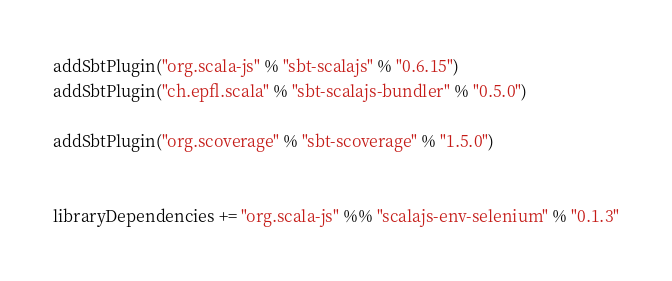Convert code to text. <code><loc_0><loc_0><loc_500><loc_500><_Scala_>addSbtPlugin("org.scala-js" % "sbt-scalajs" % "0.6.15")
addSbtPlugin("ch.epfl.scala" % "sbt-scalajs-bundler" % "0.5.0")

addSbtPlugin("org.scoverage" % "sbt-scoverage" % "1.5.0")


libraryDependencies += "org.scala-js" %% "scalajs-env-selenium" % "0.1.3"
</code> 